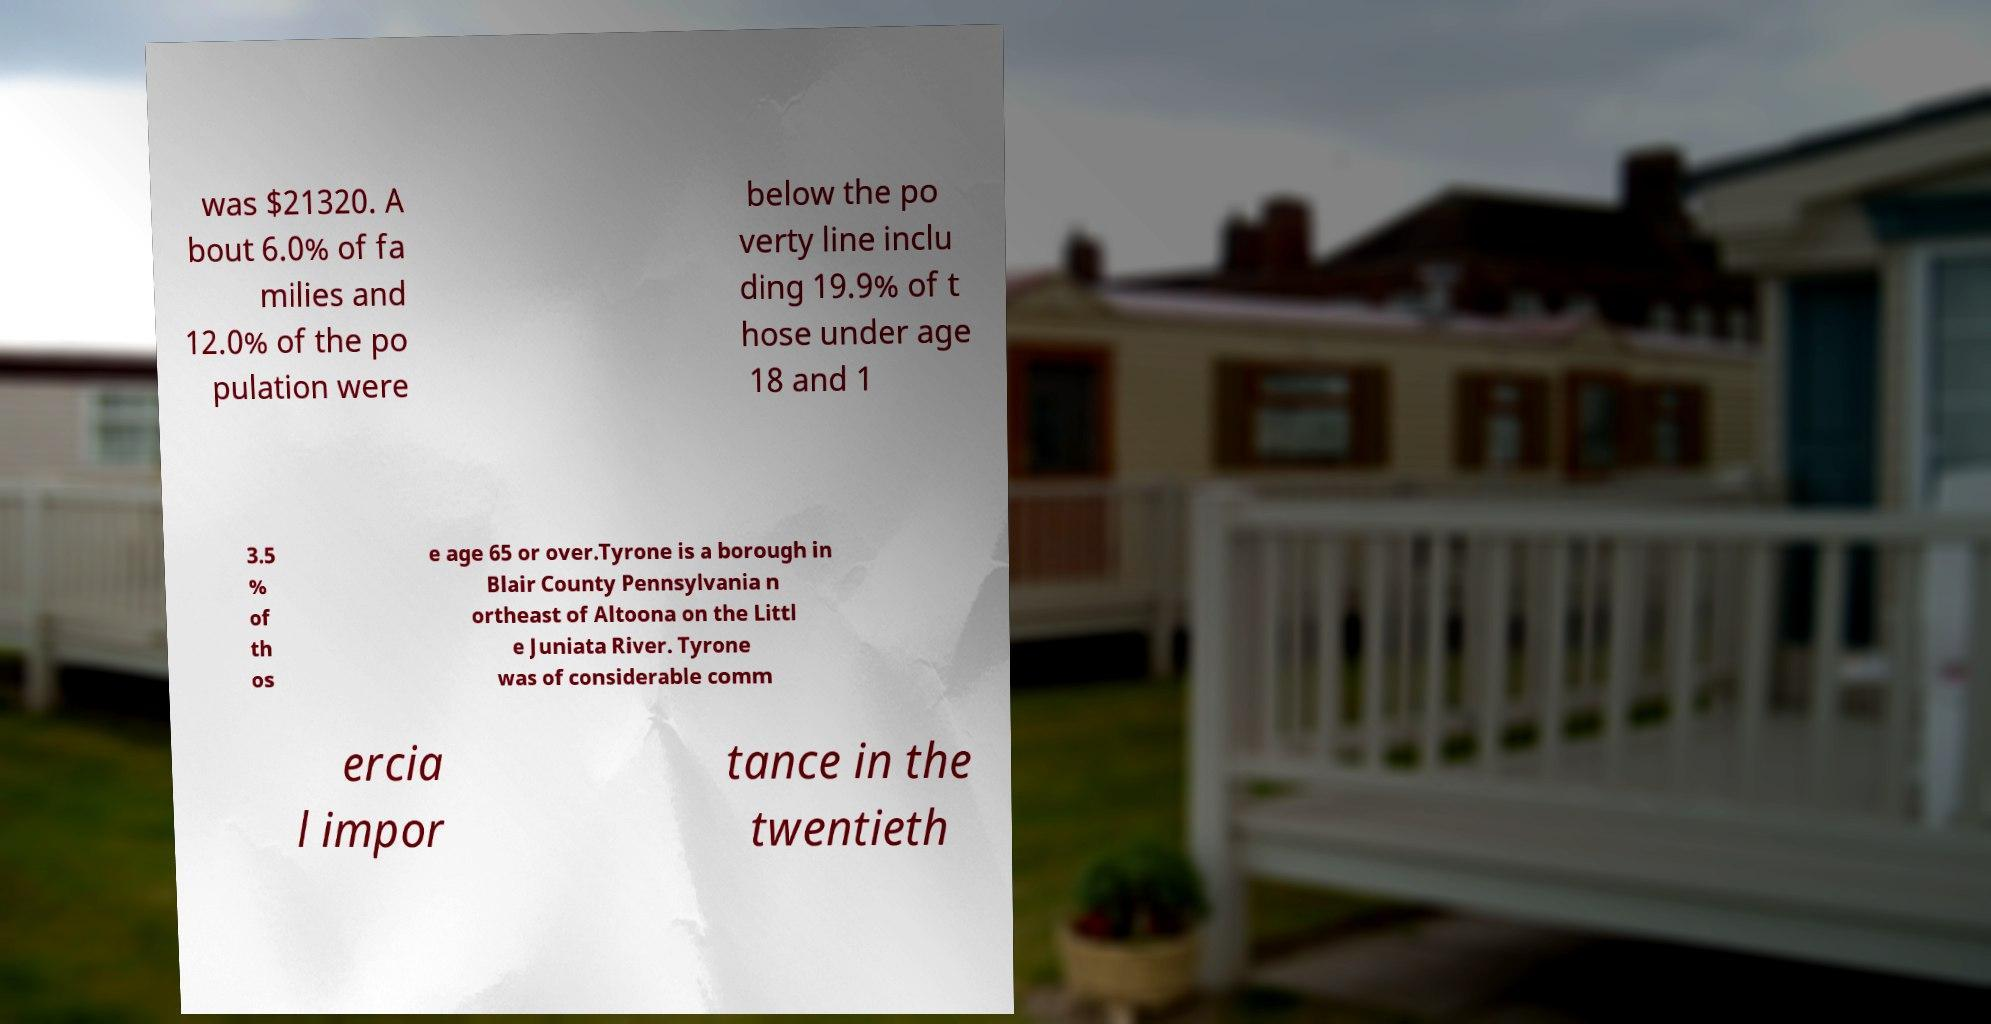Could you extract and type out the text from this image? was $21320. A bout 6.0% of fa milies and 12.0% of the po pulation were below the po verty line inclu ding 19.9% of t hose under age 18 and 1 3.5 % of th os e age 65 or over.Tyrone is a borough in Blair County Pennsylvania n ortheast of Altoona on the Littl e Juniata River. Tyrone was of considerable comm ercia l impor tance in the twentieth 